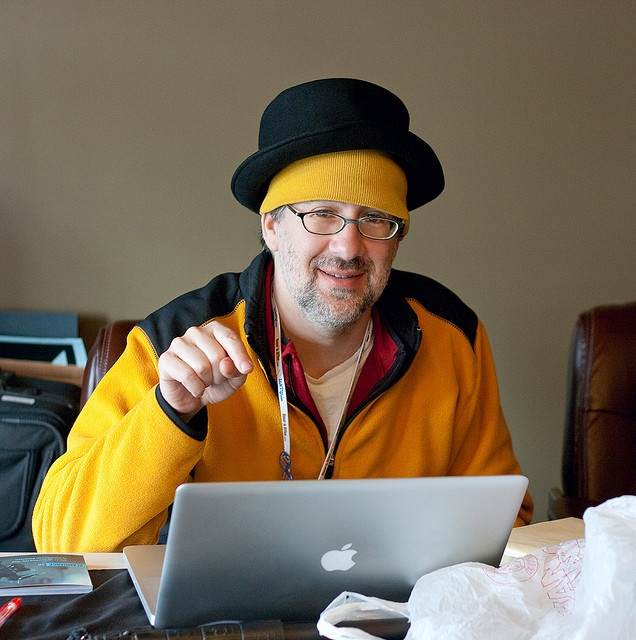Describe the objects in this image and their specific colors. I can see people in gray, black, brown, maroon, and gold tones, laptop in gray, darkgray, lightgray, and black tones, chair in gray, black, and maroon tones, and book in gray and darkgray tones in this image. 